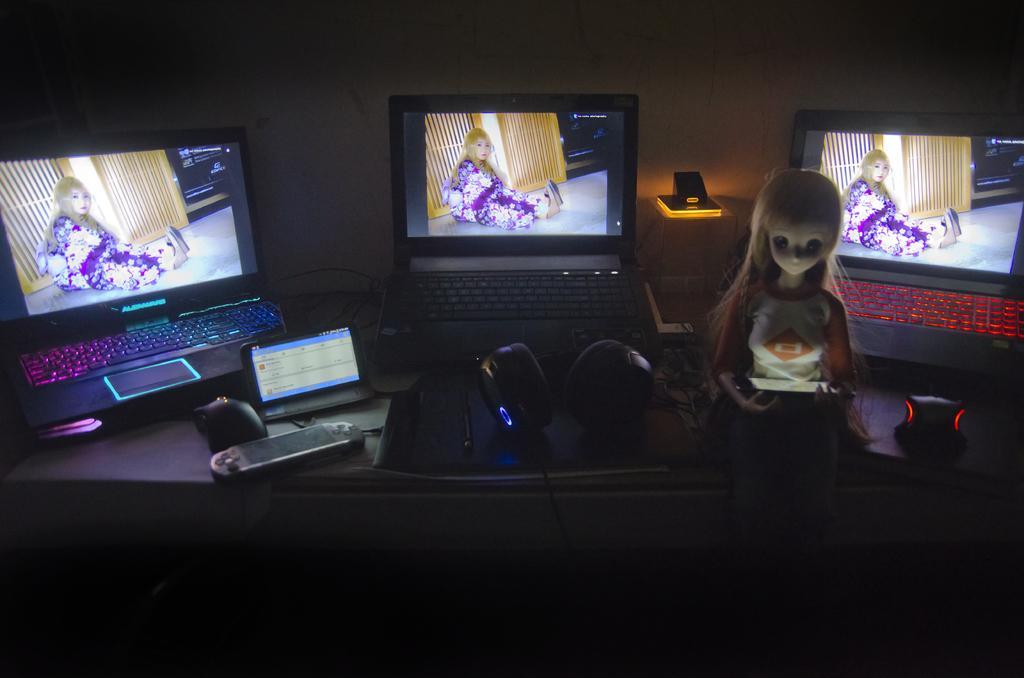Please provide a concise description of this image. This is a table. On the table there are laptops, remote, mouses, tab, and a toy. In the background there is a wall. 